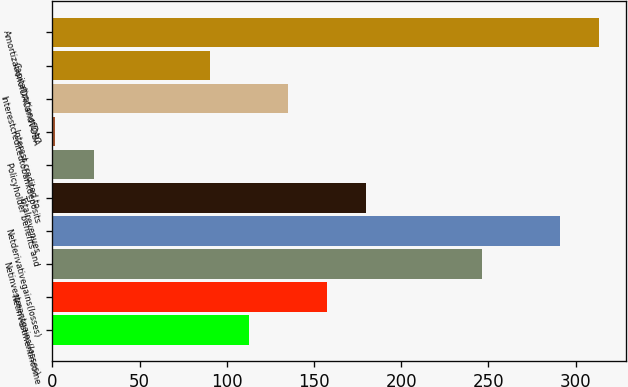Convert chart. <chart><loc_0><loc_0><loc_500><loc_500><bar_chart><ecel><fcel>Netinvestmentincome<fcel>Netinvestmentgains(losses)<fcel>Netderivativegains(losses)<fcel>Totalrevenues<fcel>Policyholder benefits and<fcel>Interest credited to<fcel>Interestcreditedtobankdeposits<fcel>CapitalizationofDAC<fcel>AmortizationofDACandVOBA<nl><fcel>112.9<fcel>157.42<fcel>246.46<fcel>290.98<fcel>179.68<fcel>23.86<fcel>1.6<fcel>135.16<fcel>90.64<fcel>313.24<nl></chart> 